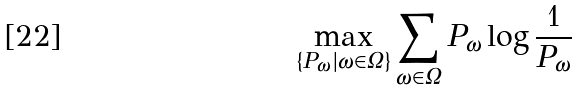Convert formula to latex. <formula><loc_0><loc_0><loc_500><loc_500>\max _ { \{ P _ { \omega } | \omega \in \Omega \} } \sum _ { \omega \in \Omega } P _ { \omega } \log { \frac { 1 } { P _ { \omega } } }</formula> 